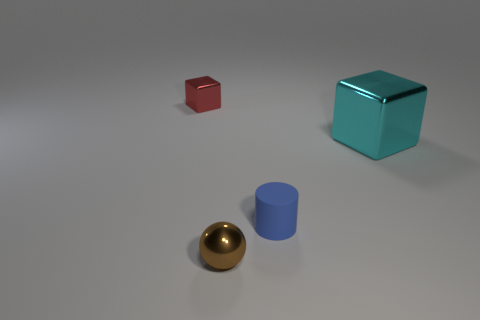What number of blue objects are either big shiny cubes or cylinders?
Ensure brevity in your answer.  1. What color is the metallic object that is behind the cube on the right side of the tiny cube?
Your response must be concise. Red. What color is the metallic block to the right of the tiny sphere?
Your answer should be compact. Cyan. Is the size of the thing that is behind the cyan cube the same as the small matte thing?
Your answer should be very brief. Yes. Is there a cyan object of the same size as the brown sphere?
Provide a succinct answer. No. There is a metal block in front of the red cube; is it the same color as the small object left of the sphere?
Offer a terse response. No. Are there any metallic blocks of the same color as the large object?
Offer a terse response. No. How many other things are the same shape as the tiny brown object?
Make the answer very short. 0. The shiny object that is on the right side of the tiny brown thing has what shape?
Offer a terse response. Cube. Is the shape of the blue thing the same as the tiny object that is behind the blue object?
Ensure brevity in your answer.  No. 